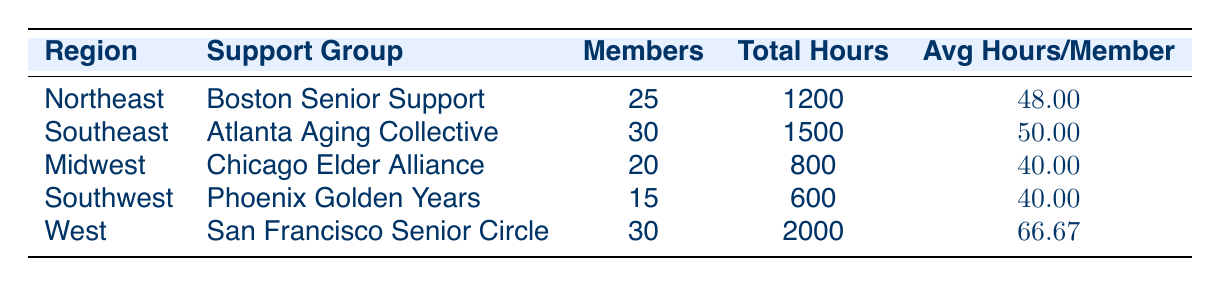What is the total volunteer hours contributed by the Boston Senior Support group? The table shows that the total hours contributed by the Boston Senior Support group in the Northeast region is listed directly in the column for "Total Hours." This value is 1200.
Answer: 1200 Which support group has the highest average hours per member? We need to compare the "Avg Hours/Member" column across all support groups. The values are: 48 for Boston Senior Support, 50 for Atlanta Aging Collective, 40 for Chicago Elder Alliance, 40 for Phoenix Golden Years, and 66.67 for San Francisco Senior Circle. The highest value is 66.67, which corresponds to the San Francisco Senior Circle.
Answer: San Francisco Senior Circle How many more total hours did the Atlanta Aging Collective contribute compared to the Chicago Elder Alliance? We look at the totals for these two groups: Atlanta Aging Collective contributed 1500 hours, while Chicago Elder Alliance contributed 800 hours. Subtracting these numbers, we have 1500 - 800 = 700 hours.
Answer: 700 Is there a support group from the Southwest region? Checking the "Region" column, there is "Phoenix Golden Years" listed under Southwest. Therefore, there is indeed a support group from that region.
Answer: Yes What is the average total volunteer hours contributed by support groups in the Northeast and Southeast regions combined? First, we find the totals for Northeast and Southeast: Boston Senior Support in the Northeast contributed 1200 hours, and Atlanta Aging Collective in the Southeast contributed 1500 hours. Adding these puts the combined total at 1200 + 1500 = 2700 hours. Now, there are 2 support groups in these regions, so the average is 2700 / 2 = 1350 hours.
Answer: 1350 Which region has the least number of members contributing volunteer hours? By looking at the "Members" column, we find the number of members for each group: 25 for Northeast, 30 for Southeast, 20 for Midwest, 15 for Southwest, and 30 for West. The least number is 15 members from Phoenix Golden Years in the Southwest region.
Answer: Southwest What is the total number of members across all the support groups? We sum the "Members" column for all support groups: 25 (Northeast) + 30 (Southeast) + 20 (Midwest) + 15 (Southwest) + 30 (West) = 120 members total.
Answer: 120 Which region has a total contribution of fewer than 1000 hours? We look at the "Total Hours" for each region: Northeast has 1200, Southeast 1500, Midwest 800, Southwest 600, and West 2000. The regions with fewer than 1000 hours are Midwest with 800 and Southwest with 600.
Answer: Midwest, Southwest 